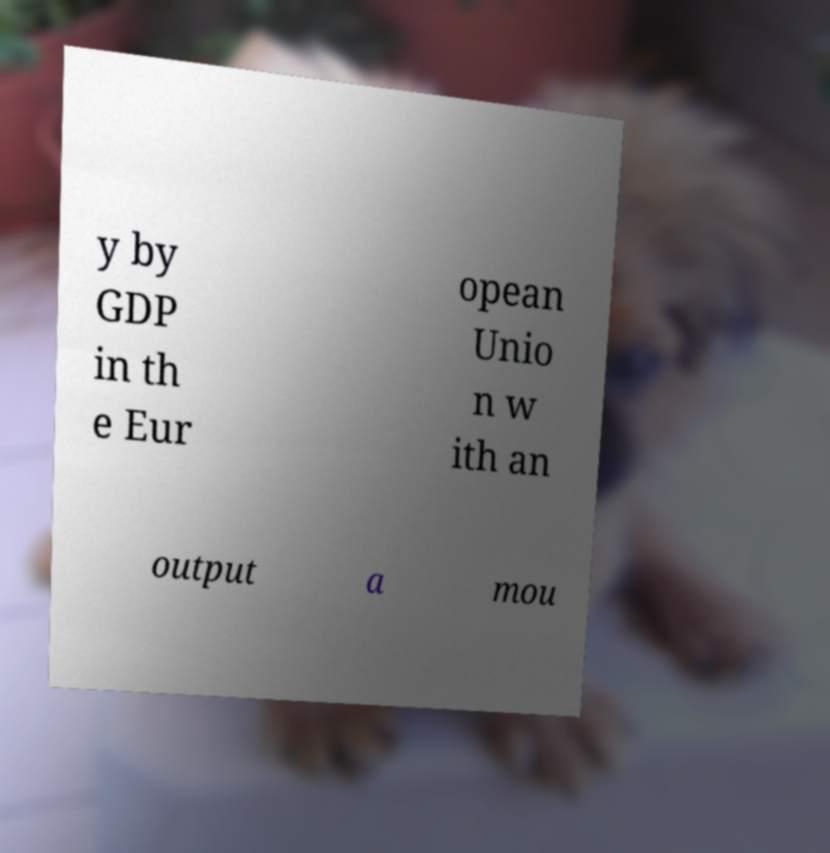Can you read and provide the text displayed in the image?This photo seems to have some interesting text. Can you extract and type it out for me? y by GDP in th e Eur opean Unio n w ith an output a mou 